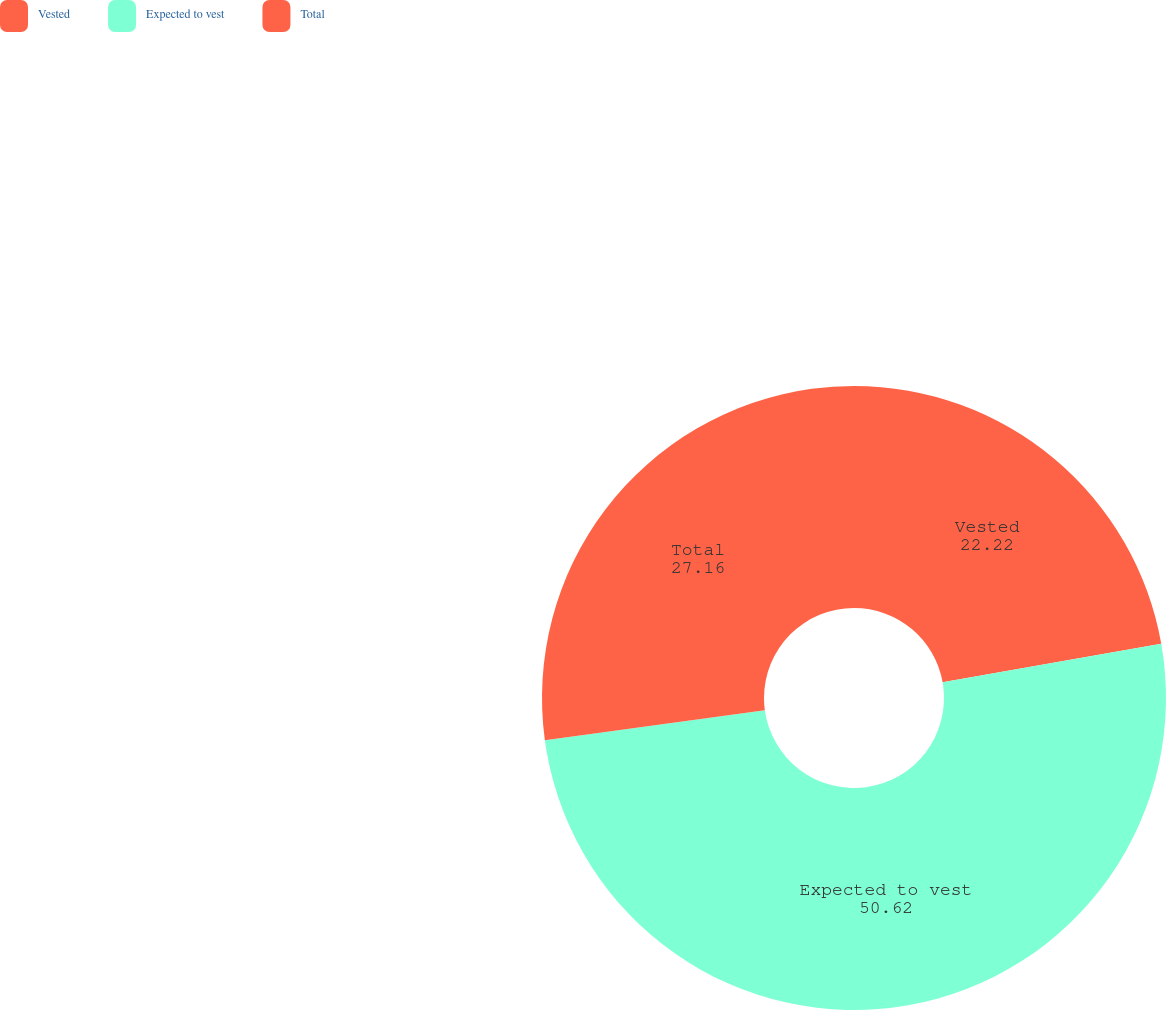<chart> <loc_0><loc_0><loc_500><loc_500><pie_chart><fcel>Vested<fcel>Expected to vest<fcel>Total<nl><fcel>22.22%<fcel>50.62%<fcel>27.16%<nl></chart> 